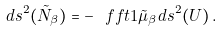Convert formula to latex. <formula><loc_0><loc_0><loc_500><loc_500>d s ^ { 2 } ( \tilde { N } _ { \beta } ) = - \ f f t { 1 } { \tilde { \mu } _ { \beta } } d s ^ { 2 } ( U ) \, .</formula> 